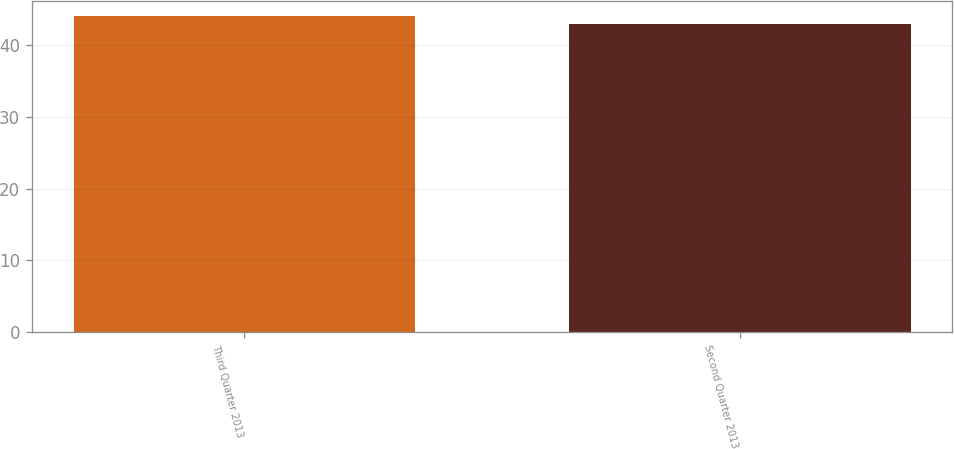Convert chart to OTSL. <chart><loc_0><loc_0><loc_500><loc_500><bar_chart><fcel>Third Quarter 2013<fcel>Second Quarter 2013<nl><fcel>44<fcel>43<nl></chart> 